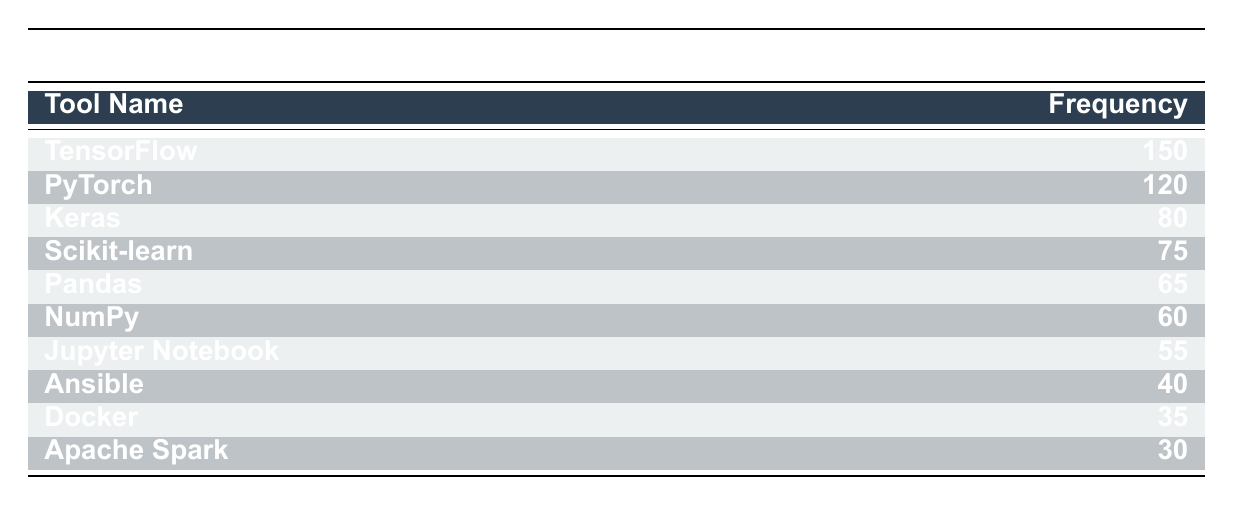What is the most frequently used software tool in Unix-based AI environments? The table shows the frequency of software tools, and TensorFlow has the highest frequency with a value of 150.
Answer: TensorFlow How many tools are listed in the frequency distribution table? The table contains a total of 10 software tools listed under the "Tool Name" column.
Answer: 10 What is the frequency of Keras? The table indicates that Keras has a frequency of 80.
Answer: 80 Is Pandas used more than Docker? Comparing the frequencies from the table, Pandas has a frequency of 65, while Docker has a frequency of 35. Since 65 is greater than 35, Pandas is indeed used more than Docker.
Answer: Yes What is the total frequency of the top three software tools? The top three tools are TensorFlow, PyTorch, and Keras with frequencies of 150, 120, and 80, respectively. Adding these gives 150 + 120 + 80 = 350.
Answer: 350 What is the average frequency of the listed software tools? To find the average, we sum all the frequencies: 150 + 120 + 80 + 75 + 65 + 60 + 55 + 40 + 35 + 30 = 710. There are 10 tools, so the average frequency is 710 divided by 10, which equals 71.
Answer: 71 Which tool has the least usage frequency, and what is its frequency? The tool with the least usage frequency is Apache Spark, which has a frequency of 30 according to the last row of the table.
Answer: Apache Spark, 30 Do more tools have a frequency greater than 50 than tools with a frequency less than or equal to 50? From the data, the tools with a frequency greater than 50 are TensorFlow, PyTorch, Keras, Scikit-learn, Pandas, NumPy, and Jupyter Notebook, totaling 7 tools. The tools with a frequency of 50 or less are Ansible, Docker, and Apache Spark, totaling 3 tools. Since 7 is greater than 3, more tools have a frequency greater than 50.
Answer: Yes What is the difference in frequency between the highest and lowest frequency tools? The highest frequency is from TensorFlow at 150, and the lowest is from Apache Spark at 30. The difference is calculated as 150 - 30 = 120.
Answer: 120 